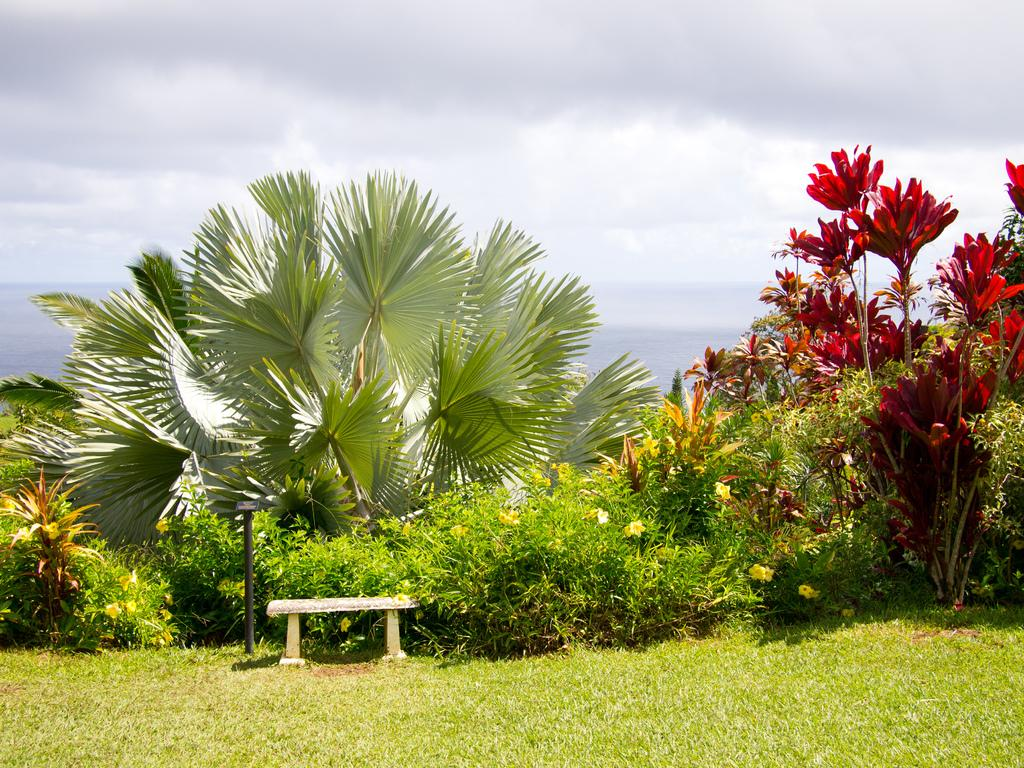What is located in the center of the image? In the center of the image, there are plants, grass, a pole, and a bench. What type of flowers can be seen in the image? There are yellow flowers in the center of the image. What can be seen in the background of the image? The sky and clouds are visible in the background of the image. How many trucks are parked near the bench in the image? There are no trucks present in the image. Is there a fireman standing next to the pole in the image? There is no fireman present in the image. 